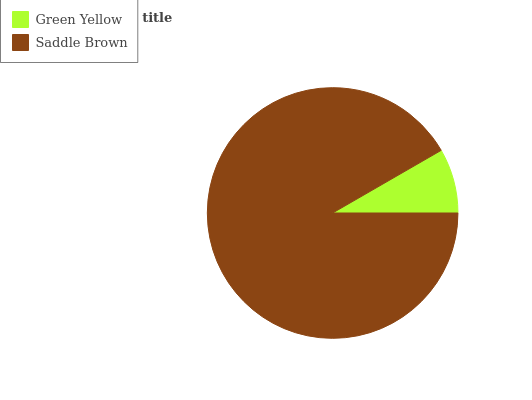Is Green Yellow the minimum?
Answer yes or no. Yes. Is Saddle Brown the maximum?
Answer yes or no. Yes. Is Saddle Brown the minimum?
Answer yes or no. No. Is Saddle Brown greater than Green Yellow?
Answer yes or no. Yes. Is Green Yellow less than Saddle Brown?
Answer yes or no. Yes. Is Green Yellow greater than Saddle Brown?
Answer yes or no. No. Is Saddle Brown less than Green Yellow?
Answer yes or no. No. Is Saddle Brown the high median?
Answer yes or no. Yes. Is Green Yellow the low median?
Answer yes or no. Yes. Is Green Yellow the high median?
Answer yes or no. No. Is Saddle Brown the low median?
Answer yes or no. No. 